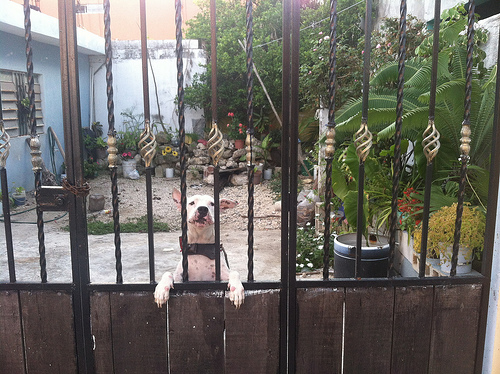<image>
Can you confirm if the dog is behind the fence? Yes. From this viewpoint, the dog is positioned behind the fence, with the fence partially or fully occluding the dog. Where is the dog in relation to the fence? Is it in front of the fence? No. The dog is not in front of the fence. The spatial positioning shows a different relationship between these objects. 